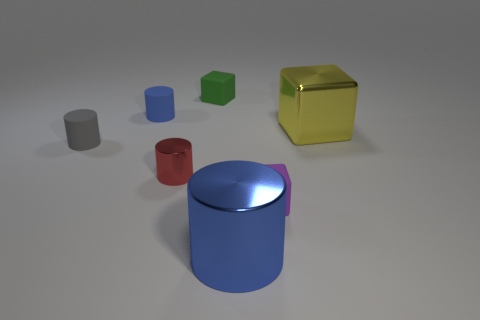How many blue cylinders must be subtracted to get 1 blue cylinders? 1 Subtract all small red cylinders. How many cylinders are left? 3 Add 1 metal objects. How many objects exist? 8 Subtract all blue cylinders. How many cylinders are left? 2 Subtract all blue blocks. How many blue cylinders are left? 2 Subtract 1 blocks. How many blocks are left? 2 Subtract all cylinders. How many objects are left? 3 Add 2 big objects. How many big objects exist? 4 Subtract 0 green cylinders. How many objects are left? 7 Subtract all red cylinders. Subtract all gray spheres. How many cylinders are left? 3 